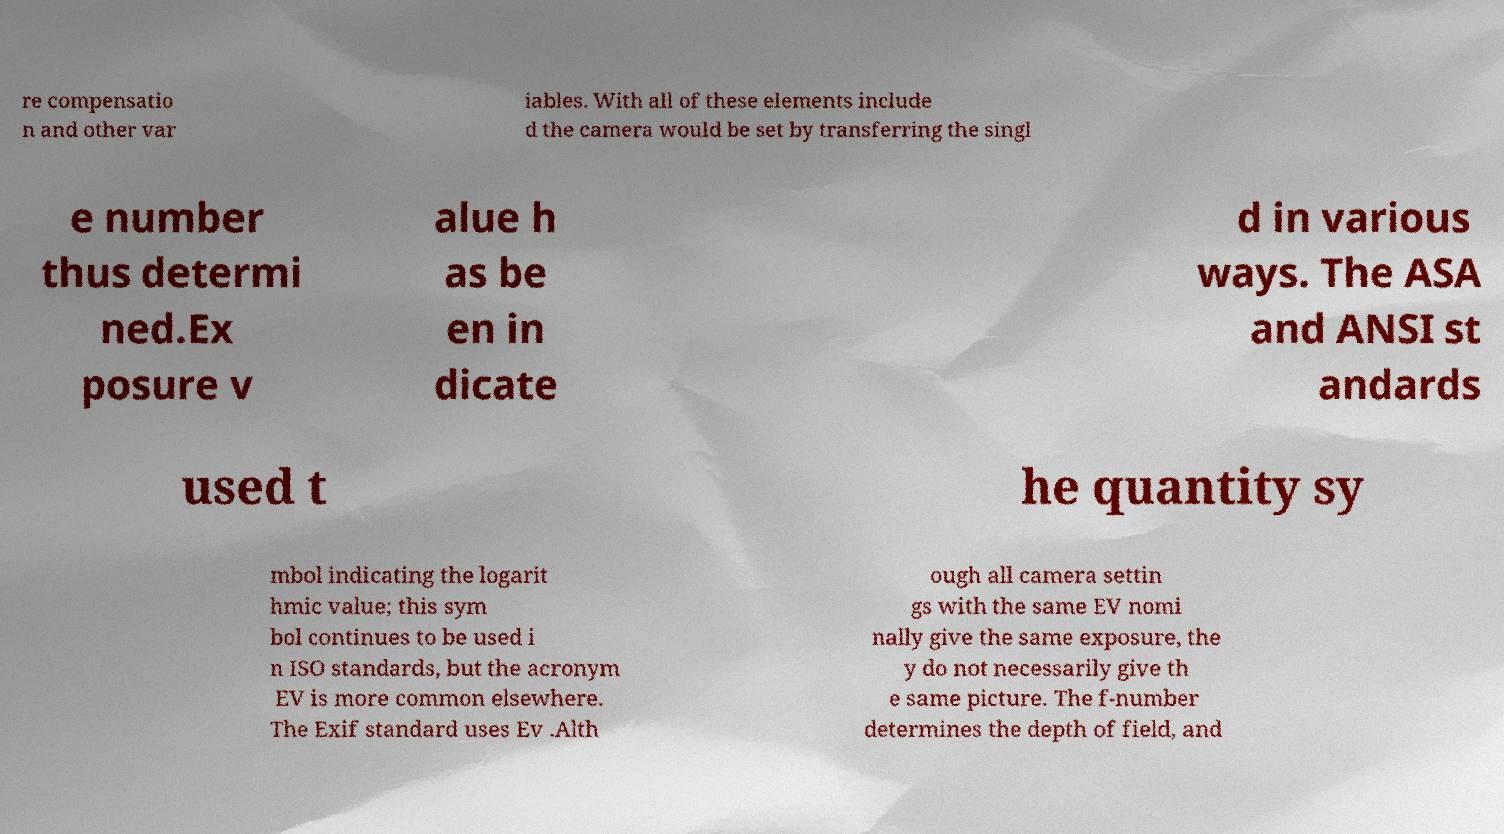I need the written content from this picture converted into text. Can you do that? re compensatio n and other var iables. With all of these elements include d the camera would be set by transferring the singl e number thus determi ned.Ex posure v alue h as be en in dicate d in various ways. The ASA and ANSI st andards used t he quantity sy mbol indicating the logarit hmic value; this sym bol continues to be used i n ISO standards, but the acronym EV is more common elsewhere. The Exif standard uses Ev .Alth ough all camera settin gs with the same EV nomi nally give the same exposure, the y do not necessarily give th e same picture. The f-number determines the depth of field, and 